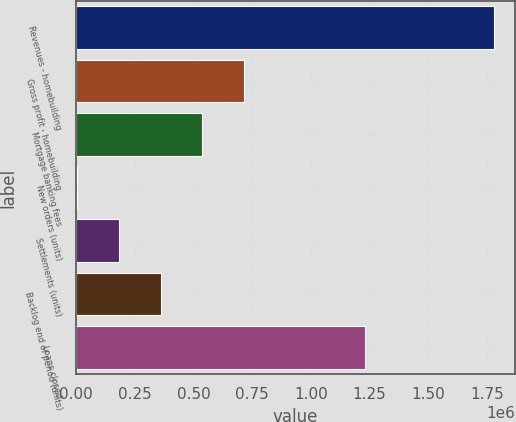Convert chart to OTSL. <chart><loc_0><loc_0><loc_500><loc_500><bar_chart><fcel>Revenues - homebuilding<fcel>Gross profit - homebuilding<fcel>Mortgage banking fees<fcel>New orders (units)<fcel>Settlements (units)<fcel>Backlog end of period (units)<fcel>Loans closed<nl><fcel>1.78149e+06<fcel>715181<fcel>537462<fcel>4306<fcel>182025<fcel>359744<fcel>1.2297e+06<nl></chart> 